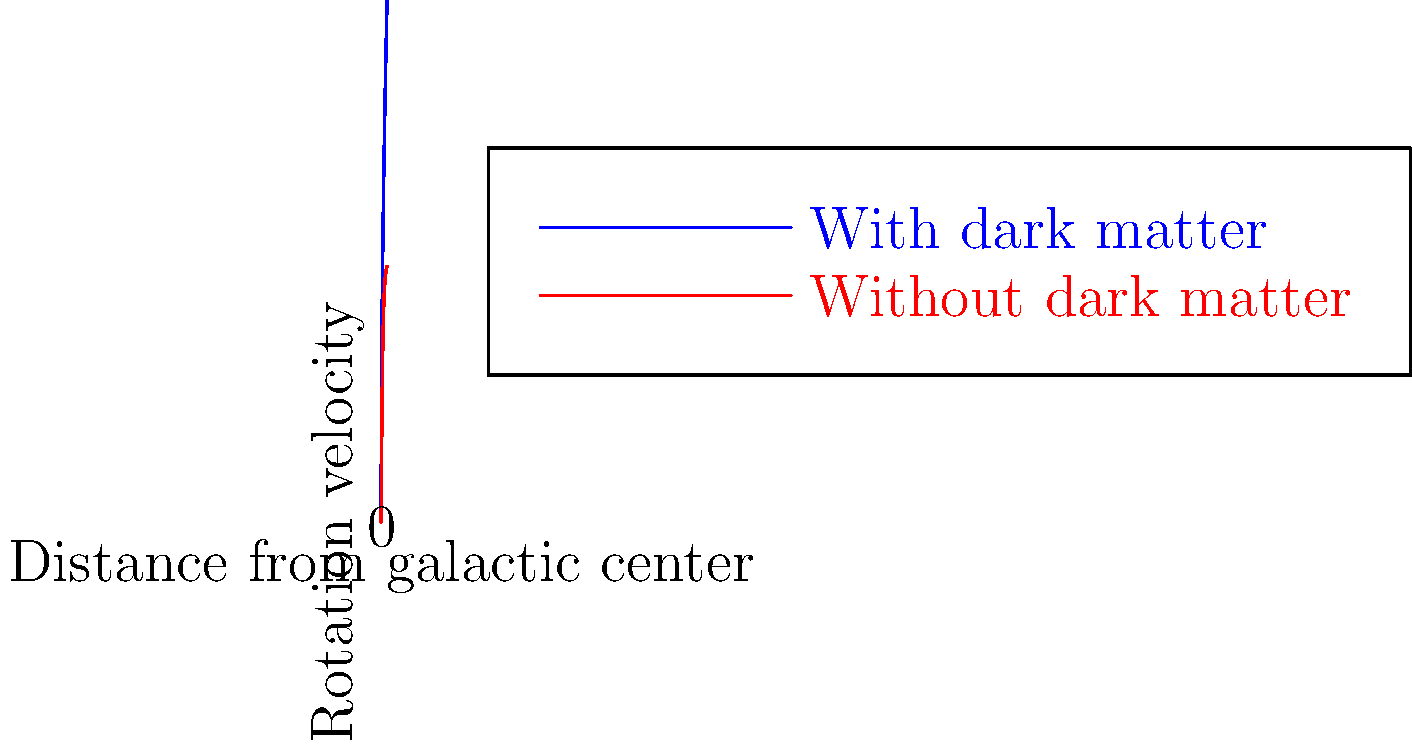Based on the rotation curves shown in the graph, which model better explains the observed flat rotation curves in the outer regions of galaxies, and how does this challenge your skepticism about dark matter's impact on galaxy formation? 1. Observe the two curves:
   - Blue curve (With dark matter): Rises quickly and then remains flat
   - Red curve (Without dark matter): Rises quickly but then begins to decline

2. Compare to observed galaxy rotation curves:
   - Actual observations show that rotation velocities remain roughly constant with increasing distance from the galactic center, even at large radii.

3. Analyze the models:
   - The dark matter model (blue curve) better matches observations, as it maintains a flat rotation curve at larger distances.
   - The model without dark matter (red curve) shows a decline in rotation velocity, which is not typically observed in real galaxies.

4. Consider the implications:
   - The flat rotation curve suggests more mass is present in the outer regions of galaxies than can be accounted for by visible matter alone.
   - This additional mass is often attributed to dark matter.

5. Challenge to skepticism:
   - The close match between the dark matter model and observed rotation curves provides strong evidence for the presence and impact of dark matter in galaxy formation.
   - This challenges the skeptical view by demonstrating that dark matter models can accurately predict and explain observed galactic behavior.

6. Alternative explanations:
   - As a skeptic, consider other possible explanations for the flat rotation curves, such as modified gravity theories (e.g., MOND).
   - Evaluate whether these alternatives can explain the observations as effectively as the dark matter model.

7. Conclusion:
   - While skepticism is valuable in science, the rotation curve evidence strongly supports the role of dark matter in galaxy formation and structure.
   - This doesn't necessarily prove dark matter exists, but it does present a significant challenge to explanations that exclude it.
Answer: Dark matter model, challenging skepticism by accurately predicting observed flat rotation curves. 